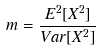Convert formula to latex. <formula><loc_0><loc_0><loc_500><loc_500>m = \frac { E ^ { 2 } [ X ^ { 2 } ] } { V a r [ X ^ { 2 } ] }</formula> 